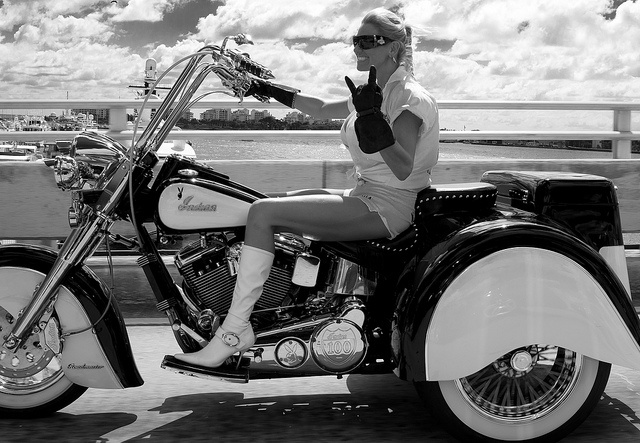Describe the objects in this image and their specific colors. I can see motorcycle in gray, black, darkgray, and lightgray tones and people in gray, darkgray, black, and lightgray tones in this image. 